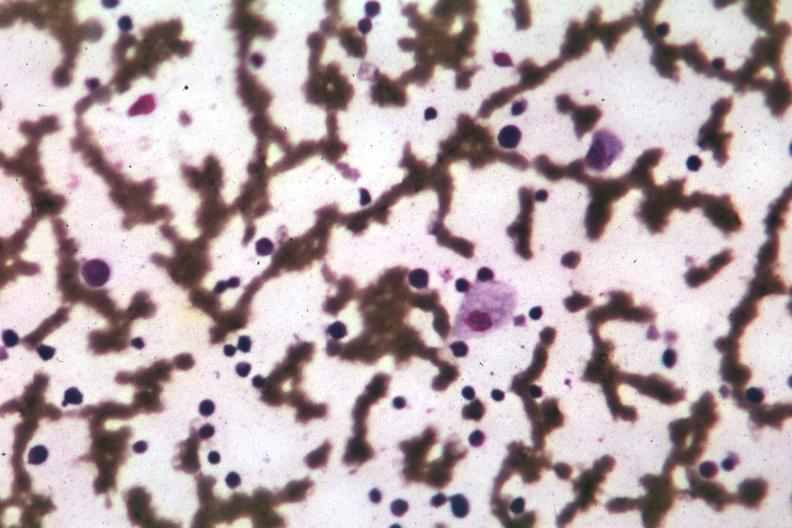s granulosa cell tumor present?
Answer the question using a single word or phrase. No 